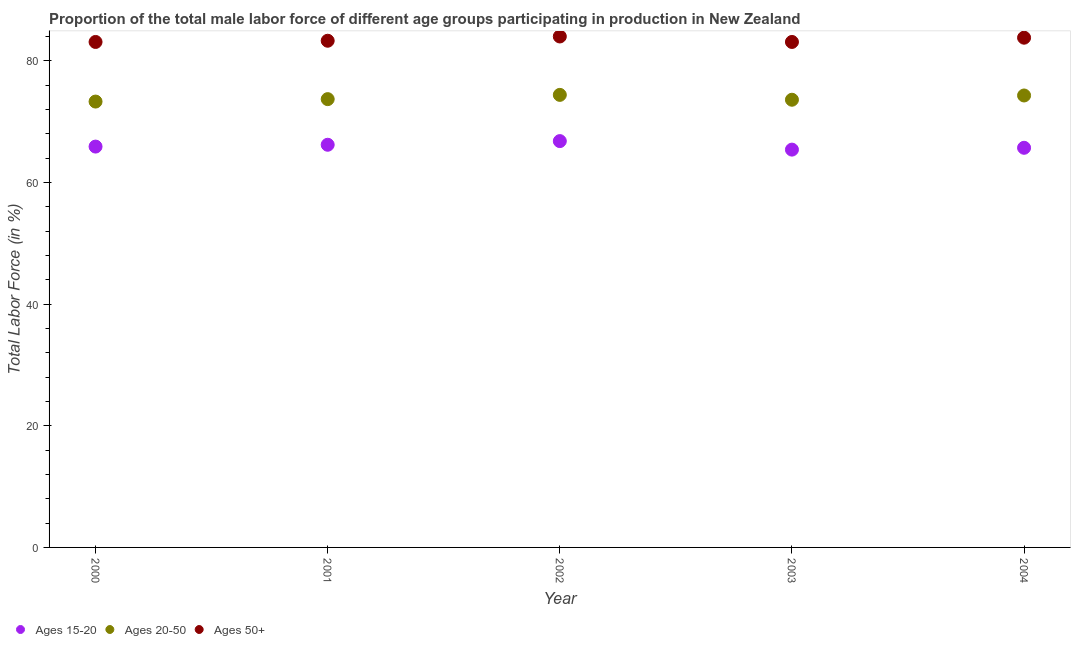How many different coloured dotlines are there?
Keep it short and to the point. 3. What is the percentage of male labor force within the age group 15-20 in 2000?
Keep it short and to the point. 65.9. Across all years, what is the maximum percentage of male labor force within the age group 15-20?
Offer a terse response. 66.8. Across all years, what is the minimum percentage of male labor force within the age group 15-20?
Make the answer very short. 65.4. In which year was the percentage of male labor force above age 50 maximum?
Your response must be concise. 2002. In which year was the percentage of male labor force within the age group 20-50 minimum?
Offer a terse response. 2000. What is the total percentage of male labor force within the age group 20-50 in the graph?
Offer a terse response. 369.3. What is the difference between the percentage of male labor force above age 50 in 2002 and that in 2003?
Offer a terse response. 0.9. What is the difference between the percentage of male labor force within the age group 20-50 in 2003 and the percentage of male labor force above age 50 in 2002?
Offer a terse response. -10.4. What is the average percentage of male labor force above age 50 per year?
Offer a terse response. 83.46. In the year 2003, what is the difference between the percentage of male labor force above age 50 and percentage of male labor force within the age group 20-50?
Provide a short and direct response. 9.5. What is the ratio of the percentage of male labor force above age 50 in 2002 to that in 2003?
Provide a short and direct response. 1.01. What is the difference between the highest and the second highest percentage of male labor force above age 50?
Give a very brief answer. 0.2. What is the difference between the highest and the lowest percentage of male labor force within the age group 20-50?
Offer a terse response. 1.1. In how many years, is the percentage of male labor force within the age group 15-20 greater than the average percentage of male labor force within the age group 15-20 taken over all years?
Make the answer very short. 2. Is the sum of the percentage of male labor force above age 50 in 2000 and 2001 greater than the maximum percentage of male labor force within the age group 20-50 across all years?
Your answer should be very brief. Yes. Is it the case that in every year, the sum of the percentage of male labor force within the age group 15-20 and percentage of male labor force within the age group 20-50 is greater than the percentage of male labor force above age 50?
Ensure brevity in your answer.  Yes. Is the percentage of male labor force above age 50 strictly less than the percentage of male labor force within the age group 15-20 over the years?
Keep it short and to the point. No. How many years are there in the graph?
Ensure brevity in your answer.  5. Does the graph contain any zero values?
Give a very brief answer. No. How many legend labels are there?
Keep it short and to the point. 3. What is the title of the graph?
Offer a terse response. Proportion of the total male labor force of different age groups participating in production in New Zealand. What is the label or title of the Y-axis?
Your answer should be very brief. Total Labor Force (in %). What is the Total Labor Force (in %) in Ages 15-20 in 2000?
Your answer should be compact. 65.9. What is the Total Labor Force (in %) in Ages 20-50 in 2000?
Provide a short and direct response. 73.3. What is the Total Labor Force (in %) in Ages 50+ in 2000?
Provide a succinct answer. 83.1. What is the Total Labor Force (in %) of Ages 15-20 in 2001?
Your answer should be very brief. 66.2. What is the Total Labor Force (in %) of Ages 20-50 in 2001?
Your answer should be very brief. 73.7. What is the Total Labor Force (in %) of Ages 50+ in 2001?
Keep it short and to the point. 83.3. What is the Total Labor Force (in %) in Ages 15-20 in 2002?
Provide a short and direct response. 66.8. What is the Total Labor Force (in %) in Ages 20-50 in 2002?
Ensure brevity in your answer.  74.4. What is the Total Labor Force (in %) in Ages 50+ in 2002?
Your response must be concise. 84. What is the Total Labor Force (in %) in Ages 15-20 in 2003?
Ensure brevity in your answer.  65.4. What is the Total Labor Force (in %) of Ages 20-50 in 2003?
Your response must be concise. 73.6. What is the Total Labor Force (in %) in Ages 50+ in 2003?
Provide a short and direct response. 83.1. What is the Total Labor Force (in %) of Ages 15-20 in 2004?
Offer a very short reply. 65.7. What is the Total Labor Force (in %) of Ages 20-50 in 2004?
Give a very brief answer. 74.3. What is the Total Labor Force (in %) of Ages 50+ in 2004?
Offer a terse response. 83.8. Across all years, what is the maximum Total Labor Force (in %) in Ages 15-20?
Offer a terse response. 66.8. Across all years, what is the maximum Total Labor Force (in %) in Ages 20-50?
Provide a short and direct response. 74.4. Across all years, what is the minimum Total Labor Force (in %) of Ages 15-20?
Your response must be concise. 65.4. Across all years, what is the minimum Total Labor Force (in %) in Ages 20-50?
Your answer should be very brief. 73.3. Across all years, what is the minimum Total Labor Force (in %) of Ages 50+?
Ensure brevity in your answer.  83.1. What is the total Total Labor Force (in %) of Ages 15-20 in the graph?
Offer a very short reply. 330. What is the total Total Labor Force (in %) of Ages 20-50 in the graph?
Your answer should be very brief. 369.3. What is the total Total Labor Force (in %) of Ages 50+ in the graph?
Give a very brief answer. 417.3. What is the difference between the Total Labor Force (in %) of Ages 15-20 in 2000 and that in 2001?
Provide a succinct answer. -0.3. What is the difference between the Total Labor Force (in %) in Ages 20-50 in 2000 and that in 2001?
Keep it short and to the point. -0.4. What is the difference between the Total Labor Force (in %) in Ages 20-50 in 2000 and that in 2002?
Offer a terse response. -1.1. What is the difference between the Total Labor Force (in %) of Ages 15-20 in 2000 and that in 2003?
Offer a terse response. 0.5. What is the difference between the Total Labor Force (in %) in Ages 20-50 in 2000 and that in 2003?
Ensure brevity in your answer.  -0.3. What is the difference between the Total Labor Force (in %) in Ages 50+ in 2000 and that in 2003?
Keep it short and to the point. 0. What is the difference between the Total Labor Force (in %) of Ages 50+ in 2000 and that in 2004?
Your answer should be compact. -0.7. What is the difference between the Total Labor Force (in %) in Ages 20-50 in 2001 and that in 2003?
Offer a terse response. 0.1. What is the difference between the Total Labor Force (in %) in Ages 15-20 in 2001 and that in 2004?
Make the answer very short. 0.5. What is the difference between the Total Labor Force (in %) in Ages 20-50 in 2001 and that in 2004?
Make the answer very short. -0.6. What is the difference between the Total Labor Force (in %) of Ages 15-20 in 2002 and that in 2003?
Make the answer very short. 1.4. What is the difference between the Total Labor Force (in %) in Ages 50+ in 2002 and that in 2003?
Your response must be concise. 0.9. What is the difference between the Total Labor Force (in %) of Ages 15-20 in 2003 and that in 2004?
Give a very brief answer. -0.3. What is the difference between the Total Labor Force (in %) of Ages 20-50 in 2003 and that in 2004?
Provide a succinct answer. -0.7. What is the difference between the Total Labor Force (in %) of Ages 15-20 in 2000 and the Total Labor Force (in %) of Ages 20-50 in 2001?
Make the answer very short. -7.8. What is the difference between the Total Labor Force (in %) in Ages 15-20 in 2000 and the Total Labor Force (in %) in Ages 50+ in 2001?
Your answer should be compact. -17.4. What is the difference between the Total Labor Force (in %) of Ages 20-50 in 2000 and the Total Labor Force (in %) of Ages 50+ in 2001?
Keep it short and to the point. -10. What is the difference between the Total Labor Force (in %) in Ages 15-20 in 2000 and the Total Labor Force (in %) in Ages 50+ in 2002?
Your answer should be compact. -18.1. What is the difference between the Total Labor Force (in %) of Ages 20-50 in 2000 and the Total Labor Force (in %) of Ages 50+ in 2002?
Keep it short and to the point. -10.7. What is the difference between the Total Labor Force (in %) in Ages 15-20 in 2000 and the Total Labor Force (in %) in Ages 20-50 in 2003?
Keep it short and to the point. -7.7. What is the difference between the Total Labor Force (in %) of Ages 15-20 in 2000 and the Total Labor Force (in %) of Ages 50+ in 2003?
Your answer should be very brief. -17.2. What is the difference between the Total Labor Force (in %) in Ages 15-20 in 2000 and the Total Labor Force (in %) in Ages 50+ in 2004?
Your response must be concise. -17.9. What is the difference between the Total Labor Force (in %) in Ages 20-50 in 2000 and the Total Labor Force (in %) in Ages 50+ in 2004?
Keep it short and to the point. -10.5. What is the difference between the Total Labor Force (in %) of Ages 15-20 in 2001 and the Total Labor Force (in %) of Ages 20-50 in 2002?
Your response must be concise. -8.2. What is the difference between the Total Labor Force (in %) of Ages 15-20 in 2001 and the Total Labor Force (in %) of Ages 50+ in 2002?
Your answer should be very brief. -17.8. What is the difference between the Total Labor Force (in %) in Ages 15-20 in 2001 and the Total Labor Force (in %) in Ages 20-50 in 2003?
Provide a succinct answer. -7.4. What is the difference between the Total Labor Force (in %) in Ages 15-20 in 2001 and the Total Labor Force (in %) in Ages 50+ in 2003?
Your answer should be compact. -16.9. What is the difference between the Total Labor Force (in %) in Ages 20-50 in 2001 and the Total Labor Force (in %) in Ages 50+ in 2003?
Keep it short and to the point. -9.4. What is the difference between the Total Labor Force (in %) in Ages 15-20 in 2001 and the Total Labor Force (in %) in Ages 50+ in 2004?
Keep it short and to the point. -17.6. What is the difference between the Total Labor Force (in %) of Ages 20-50 in 2001 and the Total Labor Force (in %) of Ages 50+ in 2004?
Your response must be concise. -10.1. What is the difference between the Total Labor Force (in %) in Ages 15-20 in 2002 and the Total Labor Force (in %) in Ages 50+ in 2003?
Provide a succinct answer. -16.3. What is the difference between the Total Labor Force (in %) in Ages 20-50 in 2002 and the Total Labor Force (in %) in Ages 50+ in 2003?
Ensure brevity in your answer.  -8.7. What is the difference between the Total Labor Force (in %) in Ages 15-20 in 2003 and the Total Labor Force (in %) in Ages 50+ in 2004?
Provide a succinct answer. -18.4. What is the difference between the Total Labor Force (in %) in Ages 20-50 in 2003 and the Total Labor Force (in %) in Ages 50+ in 2004?
Keep it short and to the point. -10.2. What is the average Total Labor Force (in %) of Ages 15-20 per year?
Your answer should be compact. 66. What is the average Total Labor Force (in %) of Ages 20-50 per year?
Provide a succinct answer. 73.86. What is the average Total Labor Force (in %) of Ages 50+ per year?
Make the answer very short. 83.46. In the year 2000, what is the difference between the Total Labor Force (in %) in Ages 15-20 and Total Labor Force (in %) in Ages 20-50?
Provide a short and direct response. -7.4. In the year 2000, what is the difference between the Total Labor Force (in %) of Ages 15-20 and Total Labor Force (in %) of Ages 50+?
Offer a terse response. -17.2. In the year 2001, what is the difference between the Total Labor Force (in %) of Ages 15-20 and Total Labor Force (in %) of Ages 50+?
Your answer should be compact. -17.1. In the year 2001, what is the difference between the Total Labor Force (in %) of Ages 20-50 and Total Labor Force (in %) of Ages 50+?
Provide a succinct answer. -9.6. In the year 2002, what is the difference between the Total Labor Force (in %) in Ages 15-20 and Total Labor Force (in %) in Ages 20-50?
Keep it short and to the point. -7.6. In the year 2002, what is the difference between the Total Labor Force (in %) of Ages 15-20 and Total Labor Force (in %) of Ages 50+?
Make the answer very short. -17.2. In the year 2002, what is the difference between the Total Labor Force (in %) of Ages 20-50 and Total Labor Force (in %) of Ages 50+?
Keep it short and to the point. -9.6. In the year 2003, what is the difference between the Total Labor Force (in %) of Ages 15-20 and Total Labor Force (in %) of Ages 20-50?
Ensure brevity in your answer.  -8.2. In the year 2003, what is the difference between the Total Labor Force (in %) in Ages 15-20 and Total Labor Force (in %) in Ages 50+?
Your response must be concise. -17.7. In the year 2003, what is the difference between the Total Labor Force (in %) in Ages 20-50 and Total Labor Force (in %) in Ages 50+?
Your answer should be very brief. -9.5. In the year 2004, what is the difference between the Total Labor Force (in %) of Ages 15-20 and Total Labor Force (in %) of Ages 50+?
Give a very brief answer. -18.1. What is the ratio of the Total Labor Force (in %) in Ages 20-50 in 2000 to that in 2001?
Offer a terse response. 0.99. What is the ratio of the Total Labor Force (in %) of Ages 15-20 in 2000 to that in 2002?
Provide a short and direct response. 0.99. What is the ratio of the Total Labor Force (in %) of Ages 20-50 in 2000 to that in 2002?
Ensure brevity in your answer.  0.99. What is the ratio of the Total Labor Force (in %) in Ages 50+ in 2000 to that in 2002?
Make the answer very short. 0.99. What is the ratio of the Total Labor Force (in %) of Ages 15-20 in 2000 to that in 2003?
Offer a very short reply. 1.01. What is the ratio of the Total Labor Force (in %) of Ages 20-50 in 2000 to that in 2003?
Make the answer very short. 1. What is the ratio of the Total Labor Force (in %) in Ages 50+ in 2000 to that in 2003?
Make the answer very short. 1. What is the ratio of the Total Labor Force (in %) in Ages 15-20 in 2000 to that in 2004?
Keep it short and to the point. 1. What is the ratio of the Total Labor Force (in %) in Ages 20-50 in 2000 to that in 2004?
Offer a terse response. 0.99. What is the ratio of the Total Labor Force (in %) of Ages 50+ in 2000 to that in 2004?
Your answer should be compact. 0.99. What is the ratio of the Total Labor Force (in %) in Ages 20-50 in 2001 to that in 2002?
Your answer should be very brief. 0.99. What is the ratio of the Total Labor Force (in %) of Ages 15-20 in 2001 to that in 2003?
Your answer should be compact. 1.01. What is the ratio of the Total Labor Force (in %) in Ages 20-50 in 2001 to that in 2003?
Provide a short and direct response. 1. What is the ratio of the Total Labor Force (in %) of Ages 50+ in 2001 to that in 2003?
Give a very brief answer. 1. What is the ratio of the Total Labor Force (in %) in Ages 15-20 in 2001 to that in 2004?
Offer a very short reply. 1.01. What is the ratio of the Total Labor Force (in %) in Ages 15-20 in 2002 to that in 2003?
Keep it short and to the point. 1.02. What is the ratio of the Total Labor Force (in %) of Ages 20-50 in 2002 to that in 2003?
Your response must be concise. 1.01. What is the ratio of the Total Labor Force (in %) of Ages 50+ in 2002 to that in 2003?
Offer a very short reply. 1.01. What is the ratio of the Total Labor Force (in %) of Ages 15-20 in 2002 to that in 2004?
Your answer should be compact. 1.02. What is the ratio of the Total Labor Force (in %) in Ages 50+ in 2002 to that in 2004?
Ensure brevity in your answer.  1. What is the ratio of the Total Labor Force (in %) in Ages 15-20 in 2003 to that in 2004?
Make the answer very short. 1. What is the ratio of the Total Labor Force (in %) in Ages 20-50 in 2003 to that in 2004?
Provide a succinct answer. 0.99. What is the difference between the highest and the second highest Total Labor Force (in %) of Ages 15-20?
Provide a succinct answer. 0.6. What is the difference between the highest and the second highest Total Labor Force (in %) in Ages 20-50?
Offer a terse response. 0.1. What is the difference between the highest and the lowest Total Labor Force (in %) of Ages 20-50?
Offer a very short reply. 1.1. What is the difference between the highest and the lowest Total Labor Force (in %) in Ages 50+?
Provide a short and direct response. 0.9. 